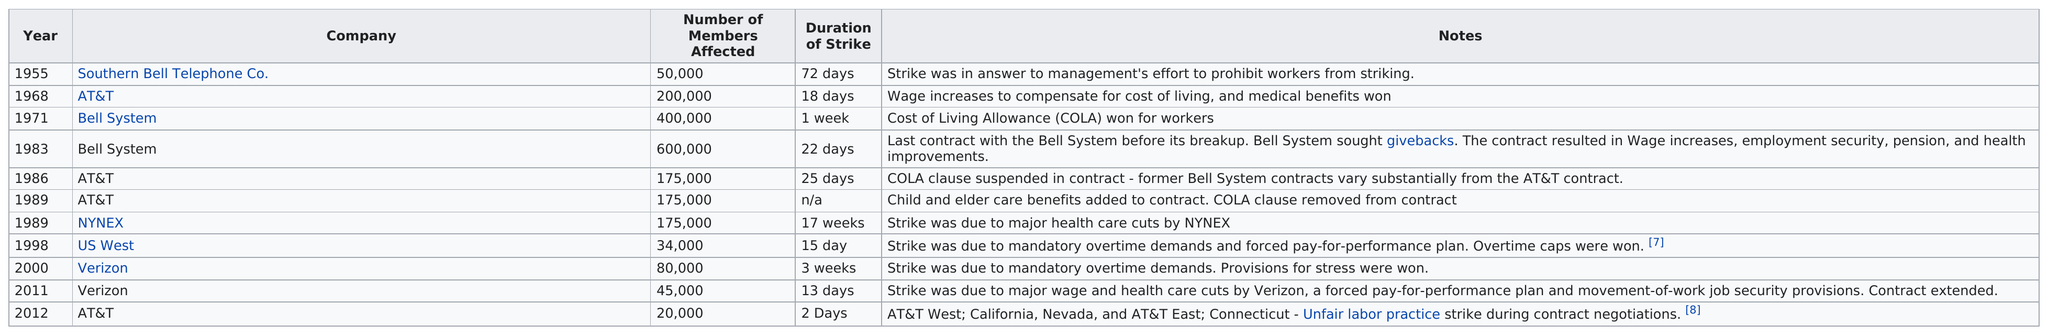Indicate a few pertinent items in this graphic. Southern Bell Telephone Company had the longest duration of strikes among all companies. In 1983, the bell system struck for a longer duration than in 1971. The most workers were affected by a strike in the year 1983. There are approximately 125,000 Verizon workers affected by the strike. On strike for 45 total days was AT&T. 